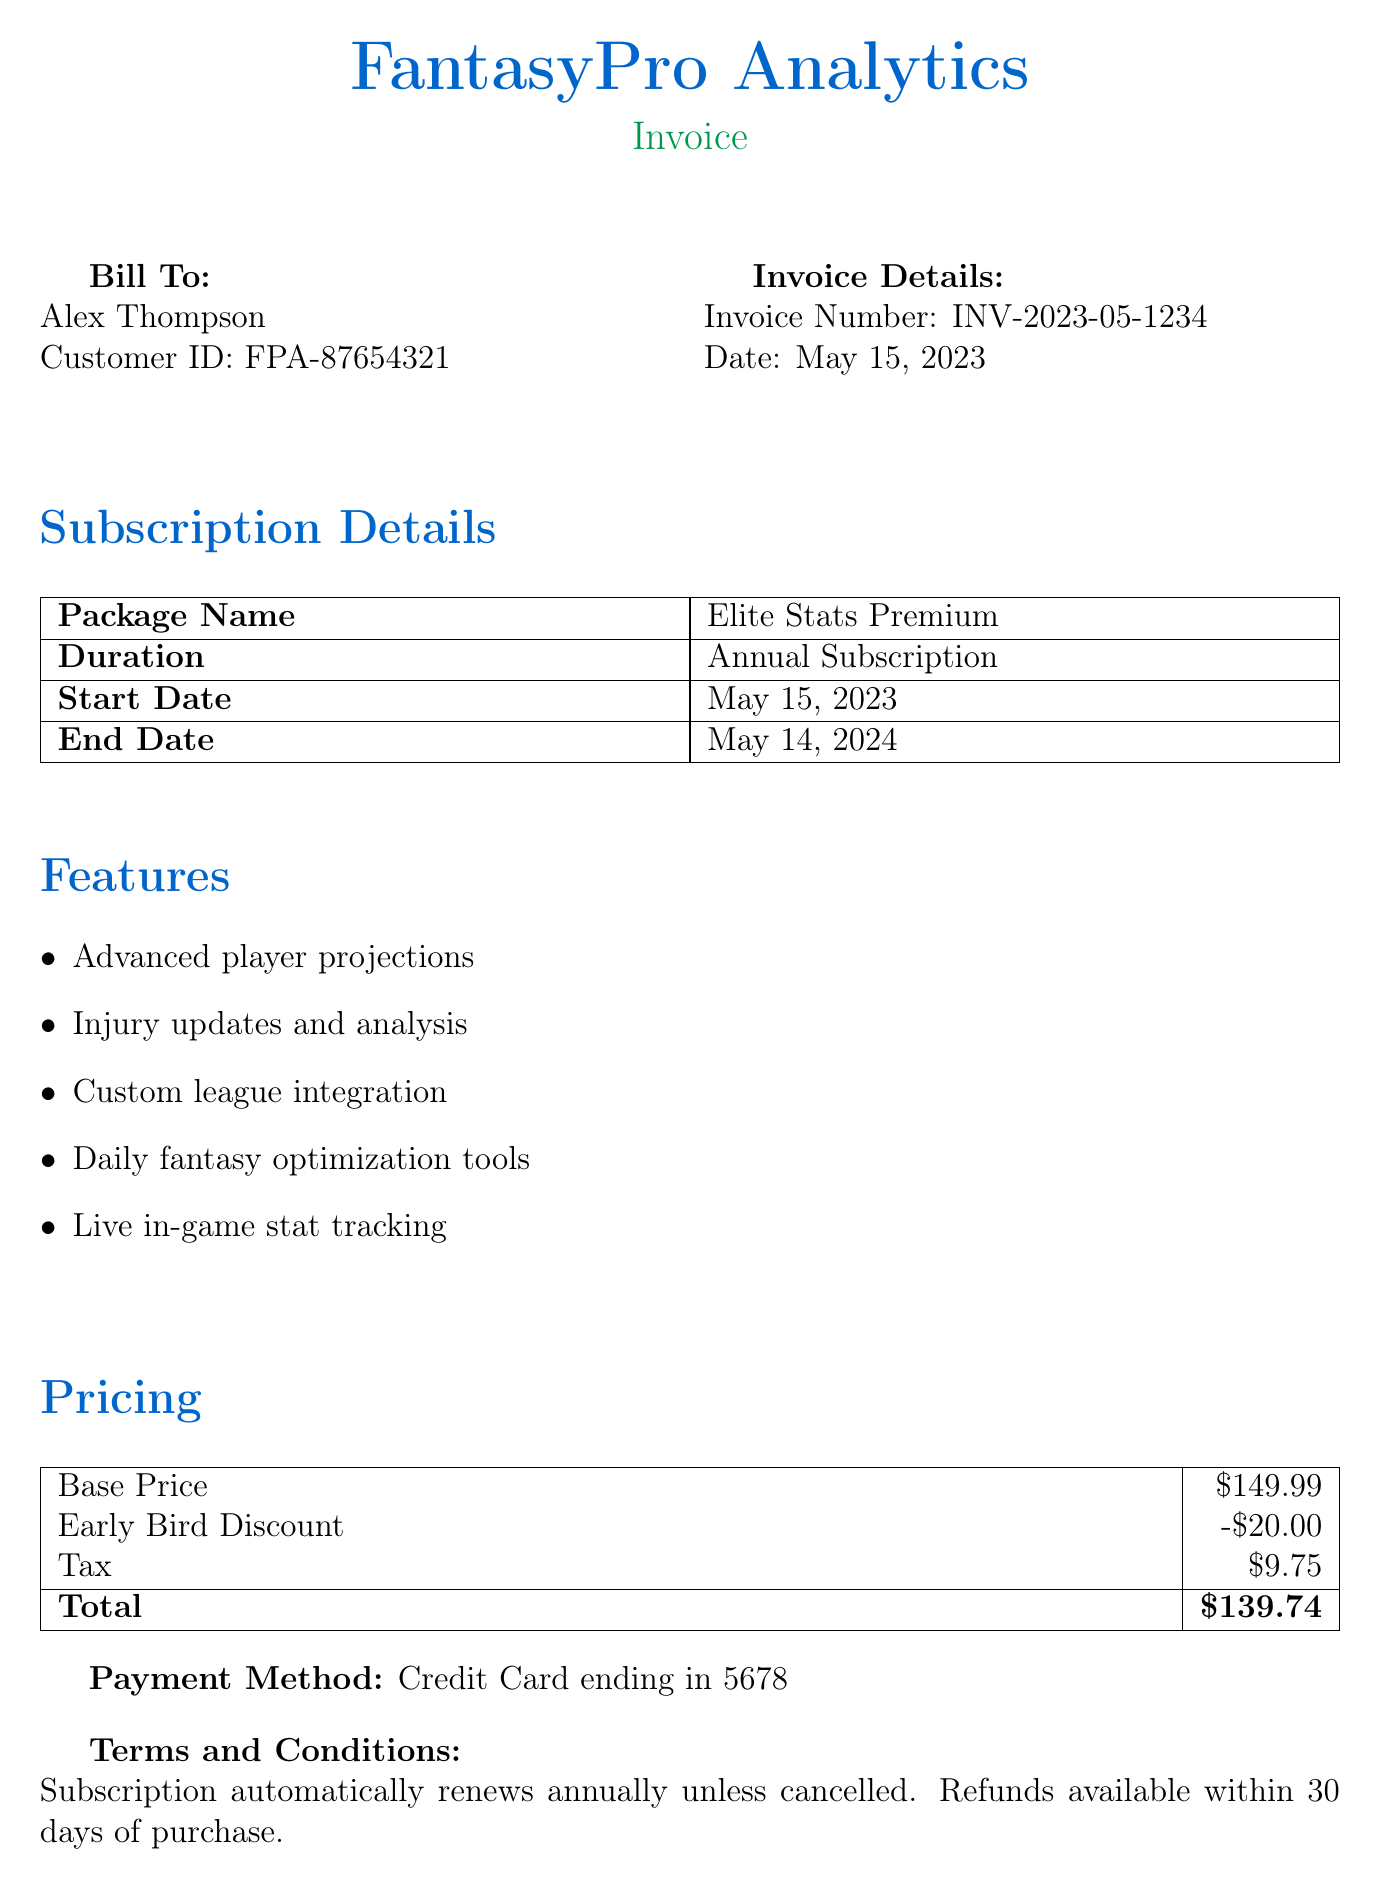What is the name of the package? The package name is listed in the subscription details section.
Answer: Elite Stats Premium What is the total amount due? The total amount due is found in the pricing section, combining base price, discounts, and tax.
Answer: $139.74 When does the subscription end? The end date of the subscription is specified in the subscription details section.
Answer: May 14, 2024 What type of payment method was used? The payment method is mentioned at the bottom of the document under the payment details.
Answer: Credit Card ending in 5678 How much was the early bird discount? The amount of the early bird discount is specified in the pricing section of the document.
Answer: -$20.00 What is the customer ID? The customer ID is provided in the bill to section along with the customer's name.
Answer: FPA-87654321 What features are included in the subscription? The features list outlines several benefits provided with the package, helping users understand its value.
Answer: Advanced player projections, Injury updates and analysis, Custom league integration, Daily fantasy optimization tools, Live in-game stat tracking What is the invoice date? The invoice date is mentioned in the invoice details section of the document.
Answer: May 15, 2023 What is the support email contact? The support contact information includes an email address provided near the end of the document.
Answer: support@fantasypro.com 